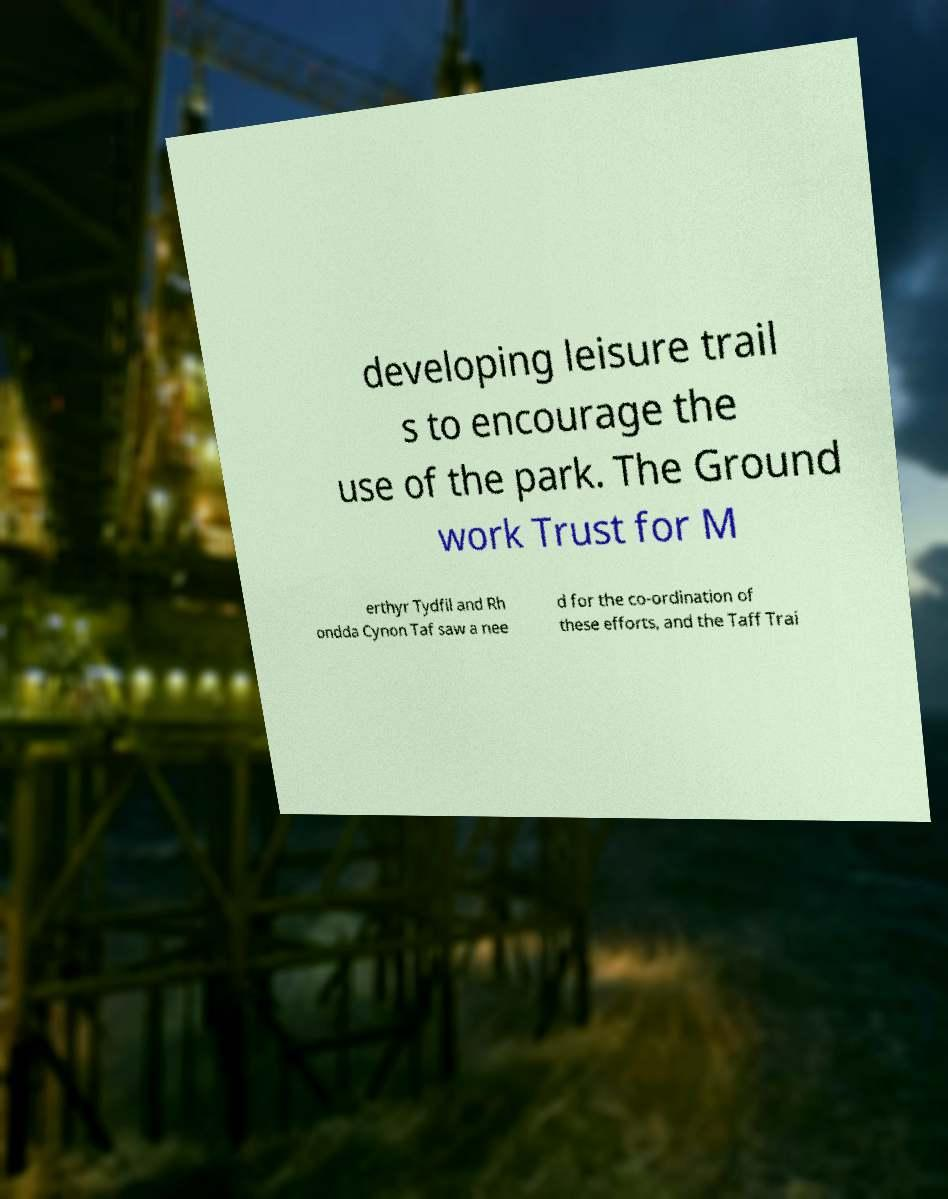For documentation purposes, I need the text within this image transcribed. Could you provide that? developing leisure trail s to encourage the use of the park. The Ground work Trust for M erthyr Tydfil and Rh ondda Cynon Taf saw a nee d for the co-ordination of these efforts, and the Taff Trai 